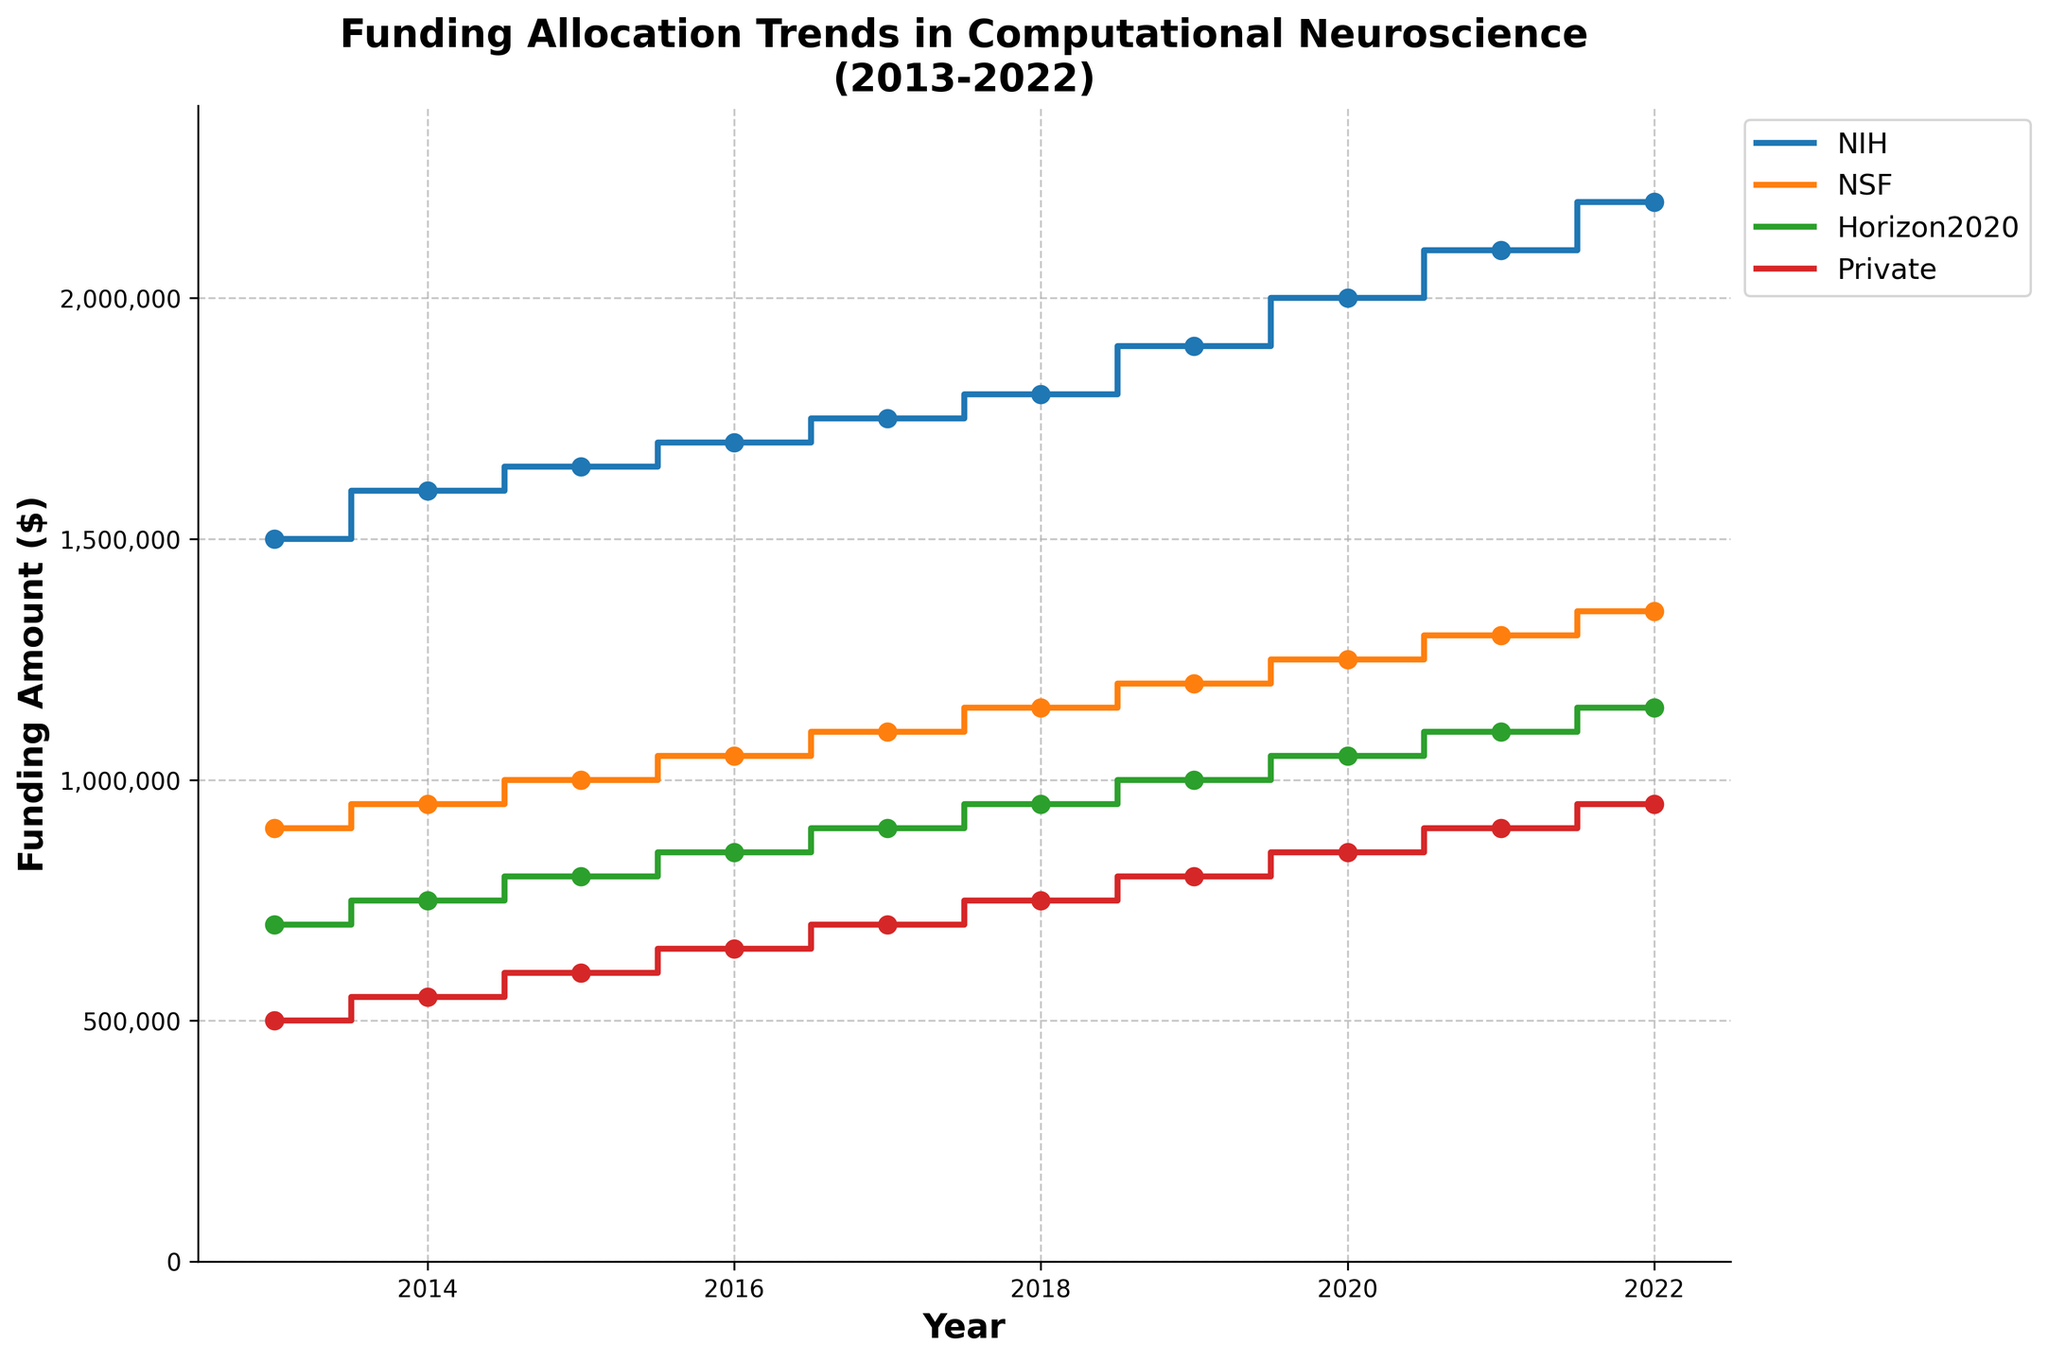What is the title of the plot? The title is prominently displayed at the top of the plot, and reading it provides the answer.
Answer: Funding Allocation Trends in Computational Neuroscience (2013-2022) Which funding source had the highest allocation in 2022? The plot shows NIH, NSF, Horizon2020, and Private funding sources. In 2022, NIH's funding curve is the highest.
Answer: NIH What is the range of funding amounts for the NIH from 2013 to 2022? The NIH curve starts at $1,500,000 in 2013 and increases to $2,200,000 in 2022. The range is obtained by subtracting the minimum value from the maximum value.
Answer: $700,000 How does the NIH funding trend compare to NSF from 2013 to 2022? Both trends show year-over-year increases, but NIH funding starts higher and grows more. At each year, NIH funding is greater than NSF.
Answer: NIH is consistently higher Which year had the closest funding amounts between Horizon2020 and Private? The curves for Horizon2020 and Private funding are closest in 2022. Visual inspection of the distances between the two curves reveals the smallest gap in 2022.
Answer: 2022 What is the average funding amount from the Private sector over the decade? To compute the average, sum all Private funding amounts from 2013 to 2022, then divide by the number of years (10). $500,000 + $550,000 + $600,000 + $650,000 + $700,000 + $750,000 + $800,000 + $850,000 + $900,000 + $950,000 = $7,250,000. Divide $7,250,000 by 10.
Answer: $725,000 By how much did NSF funding increase from 2015 to 2020? Locate NSF funding in 2015 ($1,000,000) and 2020 ($1,250,000), then subtract the 2015 value from the 2020 value.
Answer: $250,000 Which funding source shows a steadier increase, Horizon2020 or Private? By observing the plots, both sources increase steadily, but Horizon2020 shows a slightly smoother trend with fewer minor deviations.
Answer: Horizon2020 In what year did NIH funding surpass $2,000,000? Trace the NIH funding curve and find the first year where it exceeds $2,000,000. This happens in 2020.
Answer: 2020 